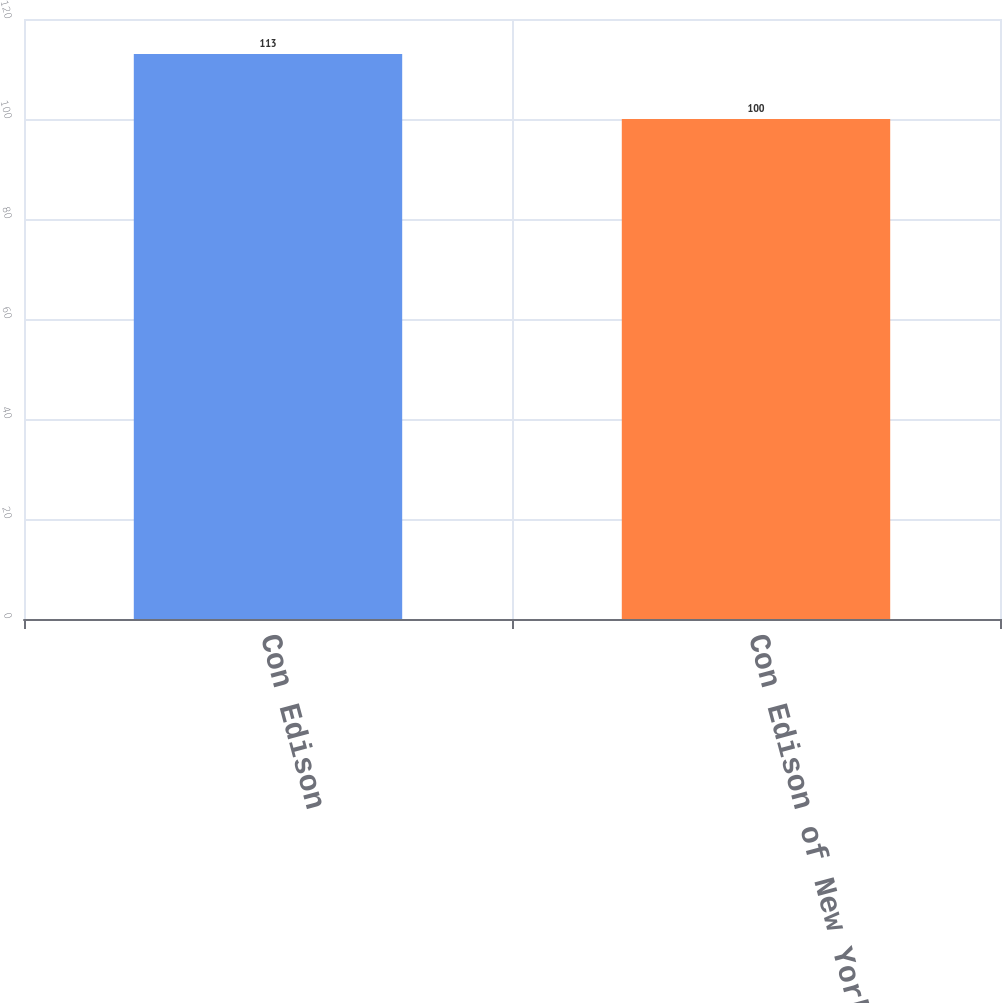Convert chart to OTSL. <chart><loc_0><loc_0><loc_500><loc_500><bar_chart><fcel>Con Edison<fcel>Con Edison of New York<nl><fcel>113<fcel>100<nl></chart> 